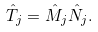<formula> <loc_0><loc_0><loc_500><loc_500>\hat { T } _ { j } = \hat { M } _ { j } \hat { N } _ { j } .</formula> 